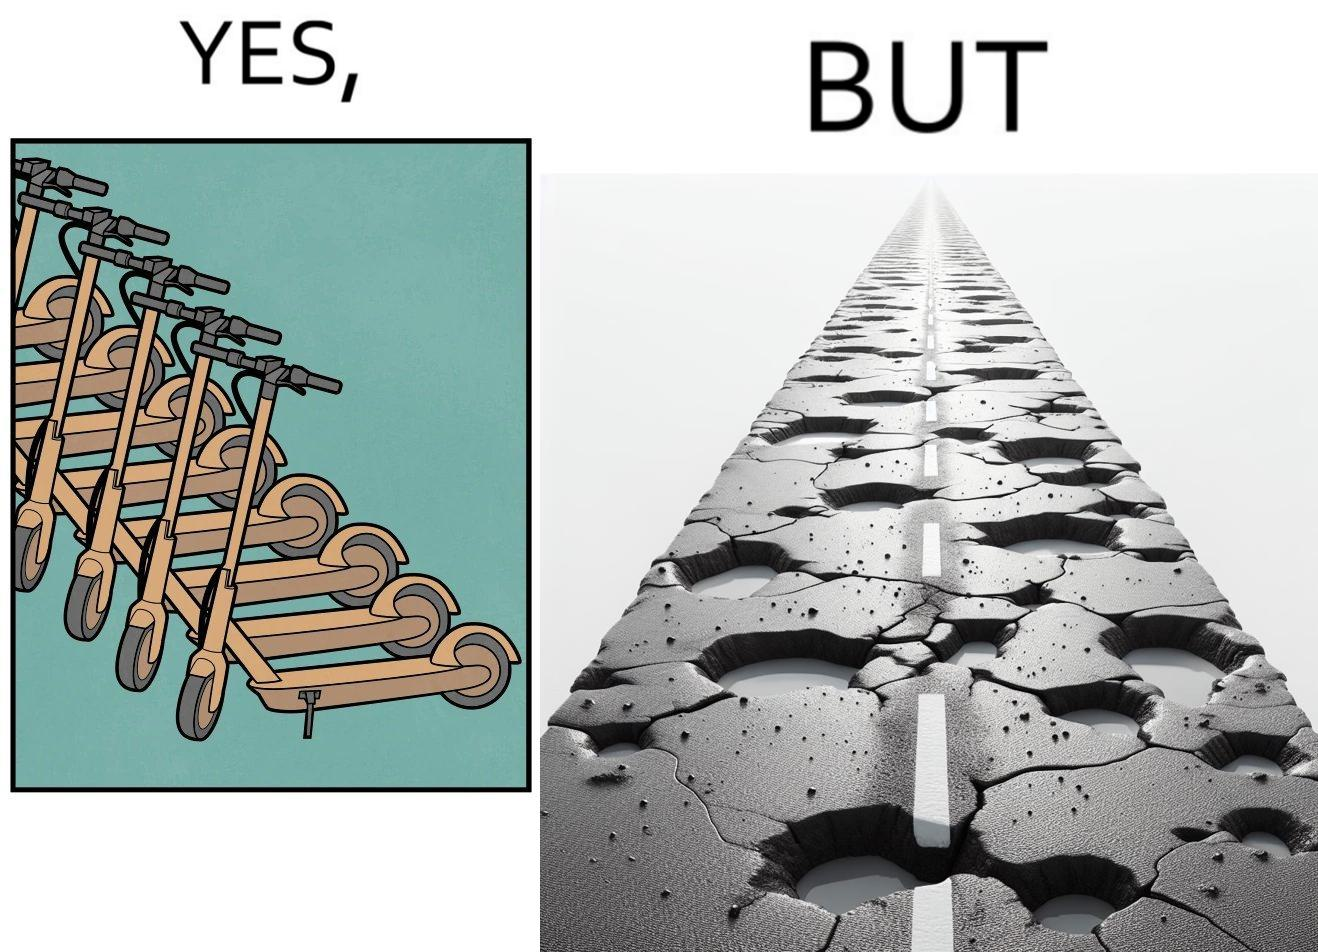What is the satirical meaning behind this image? The image is ironic, because even after when the skateboard scooters are available for someone to ride but the road has many potholes that it is not suitable to ride the scooters on such roads 